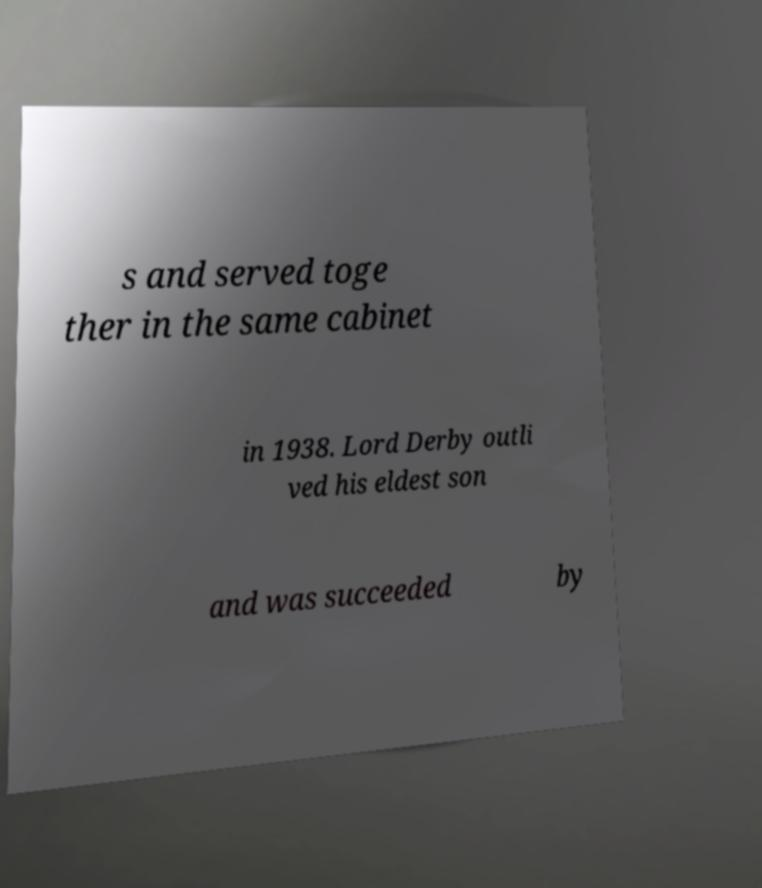What messages or text are displayed in this image? I need them in a readable, typed format. s and served toge ther in the same cabinet in 1938. Lord Derby outli ved his eldest son and was succeeded by 